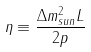Convert formula to latex. <formula><loc_0><loc_0><loc_500><loc_500>\eta \equiv \frac { \Delta m ^ { 2 } _ { s u n } L } { 2 p }</formula> 